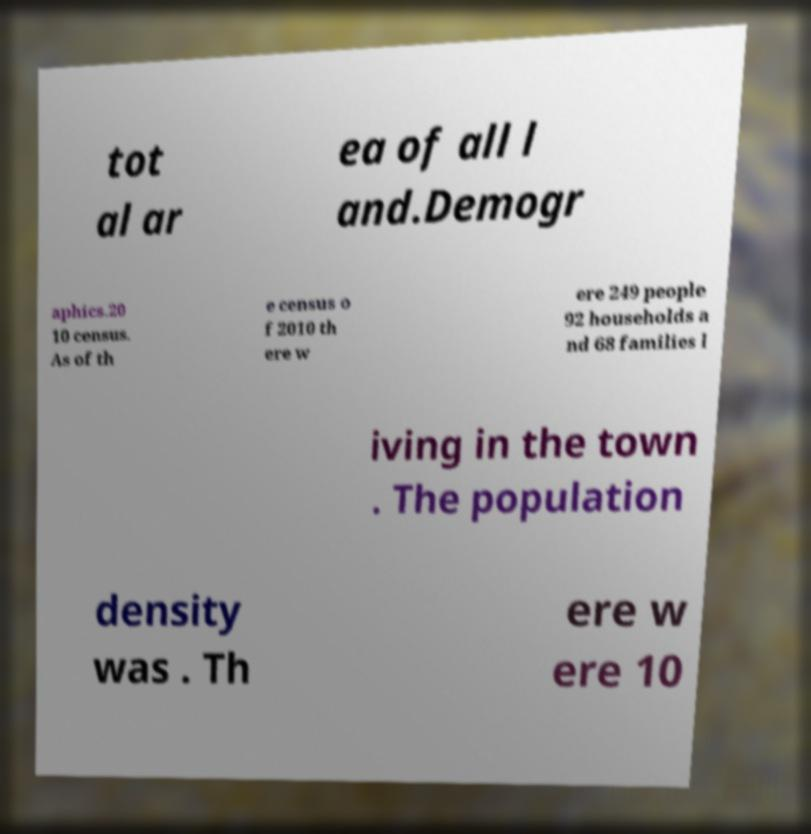Can you read and provide the text displayed in the image?This photo seems to have some interesting text. Can you extract and type it out for me? tot al ar ea of all l and.Demogr aphics.20 10 census. As of th e census o f 2010 th ere w ere 249 people 92 households a nd 68 families l iving in the town . The population density was . Th ere w ere 10 